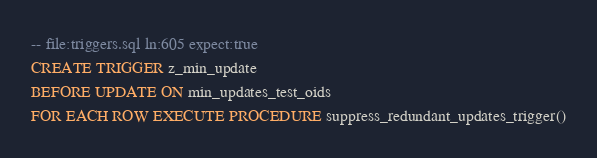<code> <loc_0><loc_0><loc_500><loc_500><_SQL_>-- file:triggers.sql ln:605 expect:true
CREATE TRIGGER z_min_update
BEFORE UPDATE ON min_updates_test_oids
FOR EACH ROW EXECUTE PROCEDURE suppress_redundant_updates_trigger()
</code> 